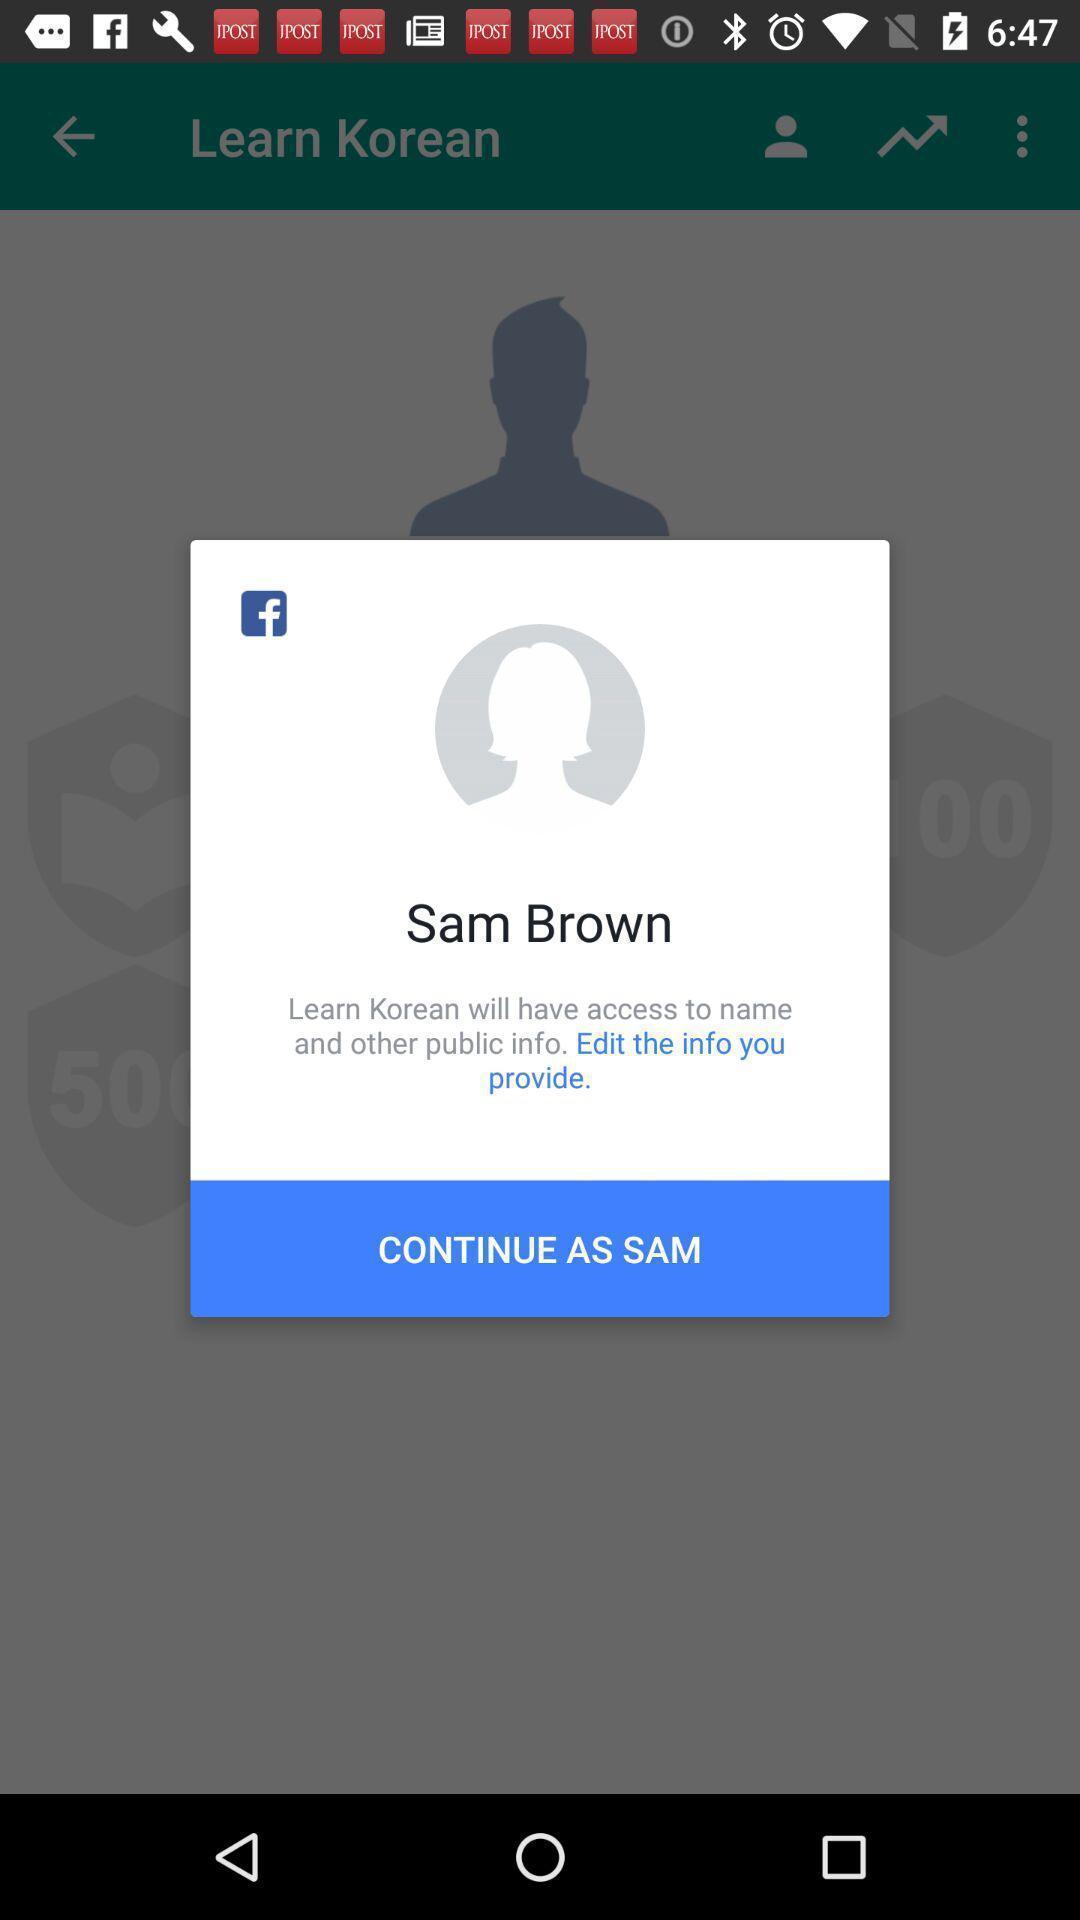Describe the visual elements of this screenshot. Pop-up window asking to continue with the profile. 